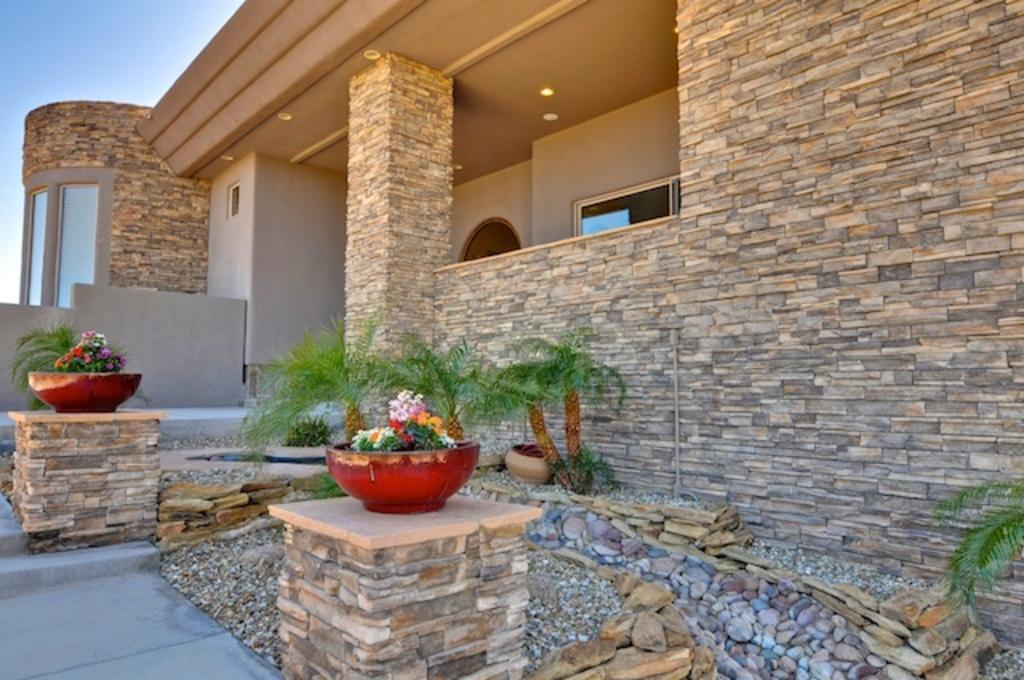What type of structure is visible in the image? There is a building in the image. What can be seen in the middle of the image? There are plants and flowers in the middle of the image. How many dogs can be seen playing in the waves in the image? There are no dogs or waves present in the image. 